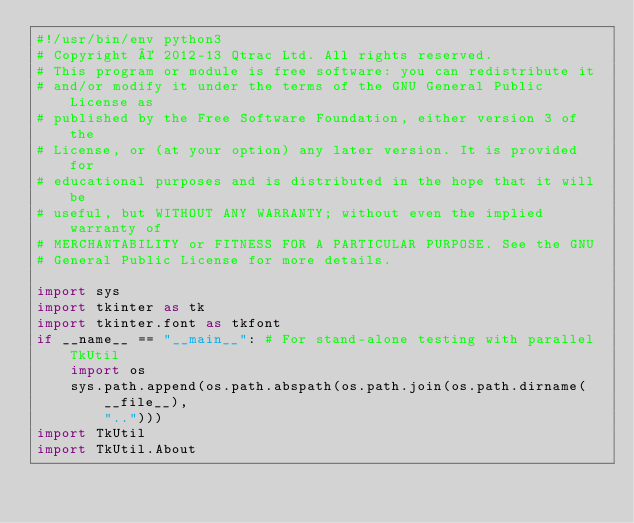<code> <loc_0><loc_0><loc_500><loc_500><_Python_>#!/usr/bin/env python3
# Copyright © 2012-13 Qtrac Ltd. All rights reserved.
# This program or module is free software: you can redistribute it
# and/or modify it under the terms of the GNU General Public License as
# published by the Free Software Foundation, either version 3 of the
# License, or (at your option) any later version. It is provided for
# educational purposes and is distributed in the hope that it will be
# useful, but WITHOUT ANY WARRANTY; without even the implied warranty of
# MERCHANTABILITY or FITNESS FOR A PARTICULAR PURPOSE. See the GNU
# General Public License for more details.

import sys
import tkinter as tk
import tkinter.font as tkfont
if __name__ == "__main__": # For stand-alone testing with parallel TkUtil
    import os
    sys.path.append(os.path.abspath(os.path.join(os.path.dirname(__file__),
        "..")))
import TkUtil
import TkUtil.About</code> 